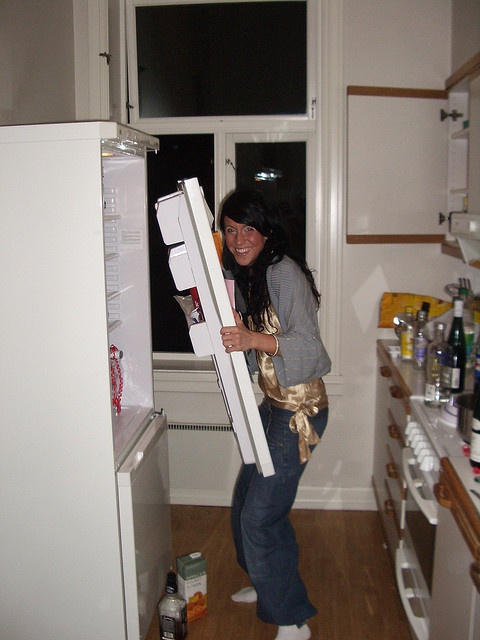Describe the objects in this image and their specific colors. I can see refrigerator in gray, lightgray, and darkgray tones, people in gray and black tones, oven in gray, darkgray, and black tones, bottle in gray, black, and darkgray tones, and bottle in gray, black, and maroon tones in this image. 